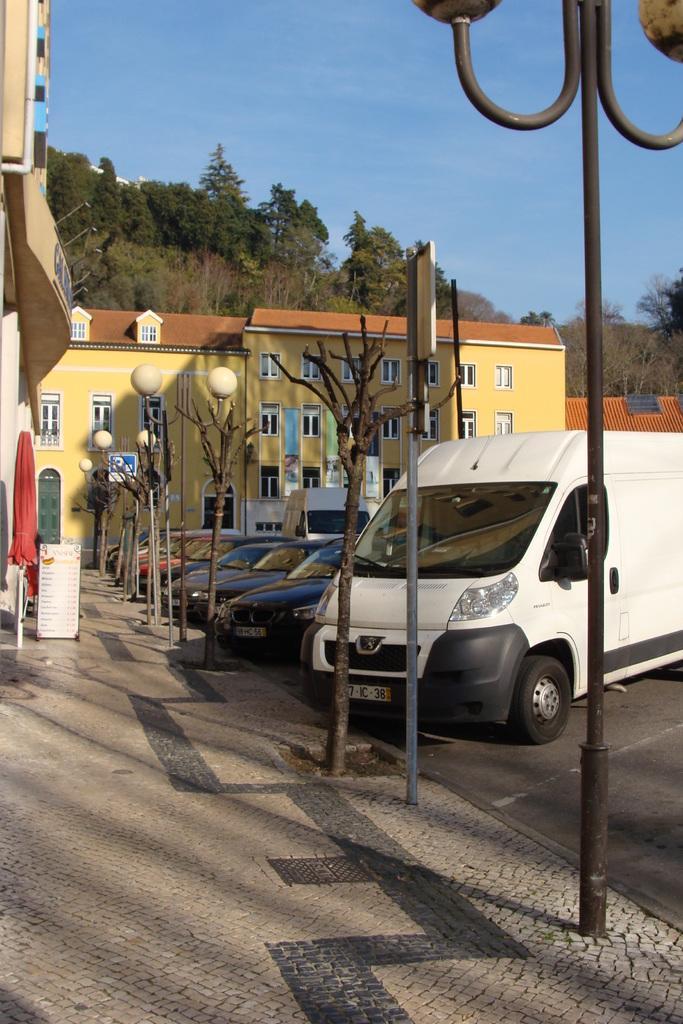Describe this image in one or two sentences. This image contains few cars and vehicles are on the road. On pavement there are few streets and few plants are on it. There is an umbrella and a board are on the pavement. In background there are few buildings, trees and sky. 